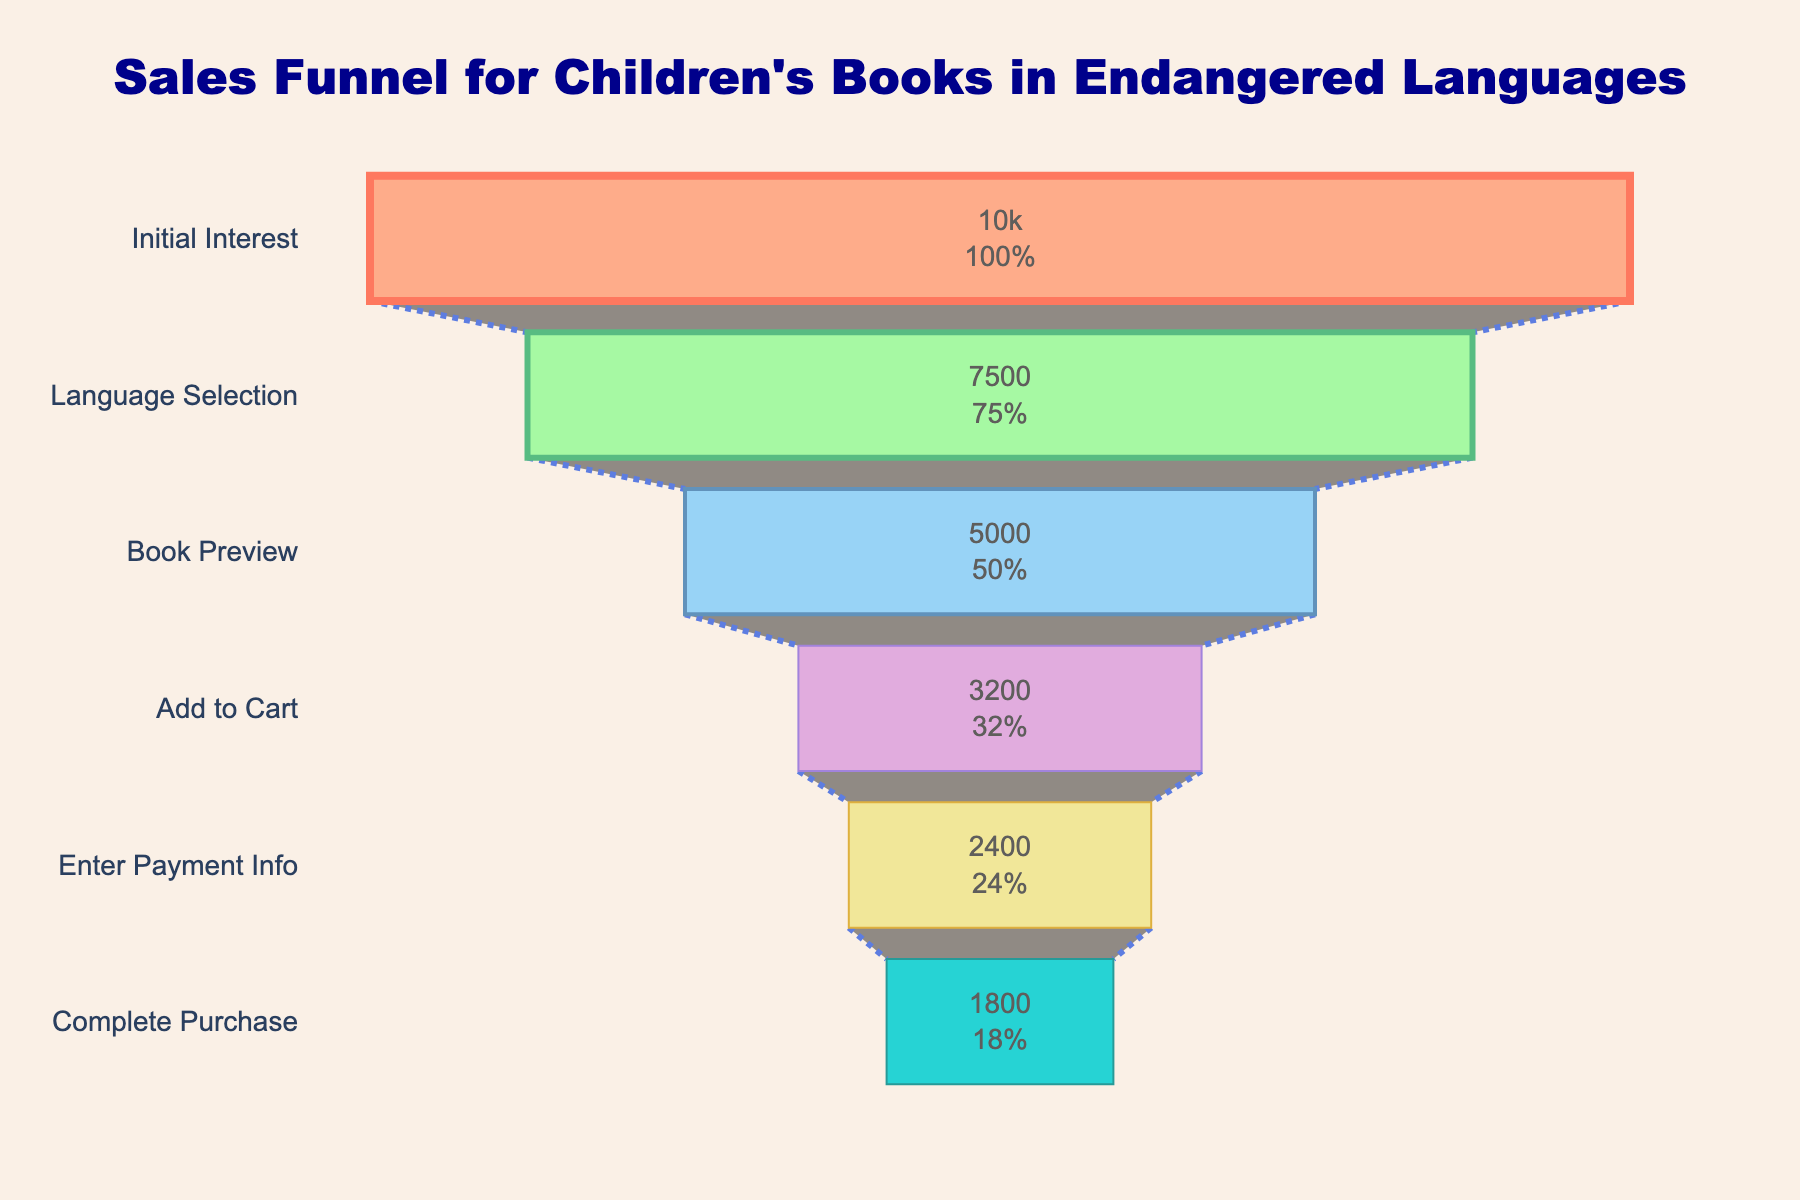What is the title of the funnel chart? The title is displayed at the top center of the chart and reads "Sales Funnel for Children's Books in Endangered Languages".
Answer: Sales Funnel for Children's Books in Endangered Languages How many stages are there in the funnel chart? The stages are listed vertically on the left side of the funnel chart. Counting them gives six stages: Initial Interest, Language Selection, Book Preview, Add to Cart, Enter Payment Info, and Complete Purchase.
Answer: Six What percentage of people who showed initial interest in the children's books eventually completed the purchase? The initial number of people is 10,000, and the number who completed the purchase is 1,800. The calculation is (1800 / 10000) * 100 = 18%.
Answer: 18% Which stage shows the largest drop in the number of people from the previous stage? By comparing the differences between each stage, we see that the largest drop is from Language Selection (7500) to Book Preview (5000). The difference is 2500.
Answer: Language Selection to Book Preview What is the fraction of people who added books to the cart but did not complete the purchase? The number who added to the cart is 3,200 and those who completed the purchase is 1,800. The difference is 3200 - 1800 = 1400. Therefore, the fraction is 1400 / 3200.
Answer: 1400/3200 At which stage do half of the initially interested people drop off? Initially, we have 10,000 people. Half of this number is 5,000. The stage where the number of people drops to this or lower is Book Preview, which has 5,000 people remaining.
Answer: Book Preview What is the difference in the number of people between the stages Add to Cart and Enter Payment Info? The number of people in Add to Cart is 3,200 and in Enter Payment Info is 2,400. The difference is 3200 - 2400 = 800.
Answer: 800 How many more people selected the language than those who completed the purchase? The number who selected the language is 7,500 and those who completed the purchase is 1,800. The difference is 7500 - 1800 = 5,700.
Answer: 5,700 What percentage of people go from adding to cart to entering payment info? The number who added to the cart is 3,200 and those who entered payment info is 2,400. The percentage is (2400 / 3200) * 100 = 75%.
Answer: 75% Which stage has the smallest drop in the number of people from the previous stage? By comparing the differences between each stage, the smallest drop is from Enter Payment Info (2400) to Complete Purchase (1800), with a difference of 600.
Answer: Enter Payment Info to Complete Purchase 